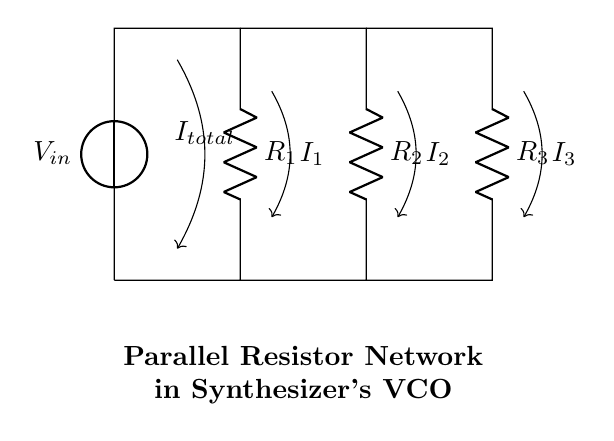What is the input voltage in the circuit? The input voltage is labeled as V_in in the circuit diagram, indicating that it is the source voltage providing power to the system.
Answer: V_in What type of resistors are used in this circuit? The circuit contains three resistors, R_1, R_2, and R_3, which are all represented as simple resistive components.
Answer: Resistors How many resistors are in the parallel network? There are three resistors (R_1, R_2, R_3) arranged in parallel based on the connections shown in the circuit.
Answer: Three What does the total current represent in this circuit? The total current I_total, represented by the arrow pointing down from the voltage source, indicates the sum of all currents flowing through the branches of the parallel resistors.
Answer: Total current If R_1 is 1k ohm, R_2 is 2k ohm, and R_3 is 3k ohm, what will be the total current through the circuit if V_in is 6V? To find the total current, first calculate the equivalent resistance R_eq using the formula for parallel resistors: 1/R_eq = 1/R_1 + 1/R_2 + 1/R_3. Thus, 1/R_eq = 1/1000 + 1/2000 + 1/3000 = 0.001 + 0.0005 + 0.000333... = 0.001833... R_eq = 1 / 0.001833... = 545.45 ohms (approximately). Then, use Ohm's law (I = V / R) to find the total current: I_total = V_in / R_eq = 6V / 545.45 ohms ≈ 0.0110 A or 11.0 mA.
Answer: Approximately 11.0 mA How does the current divide among the resistors? The current divides across the parallel resistors inversely proportional to their resistances, meaning that the resistor with the lowest resistance (R_1) receives the highest current, while the one with the highest resistance (R_3) receives the least current. The division can be calculated using Kirchhoff's current law.
Answer: Inversely proportional 